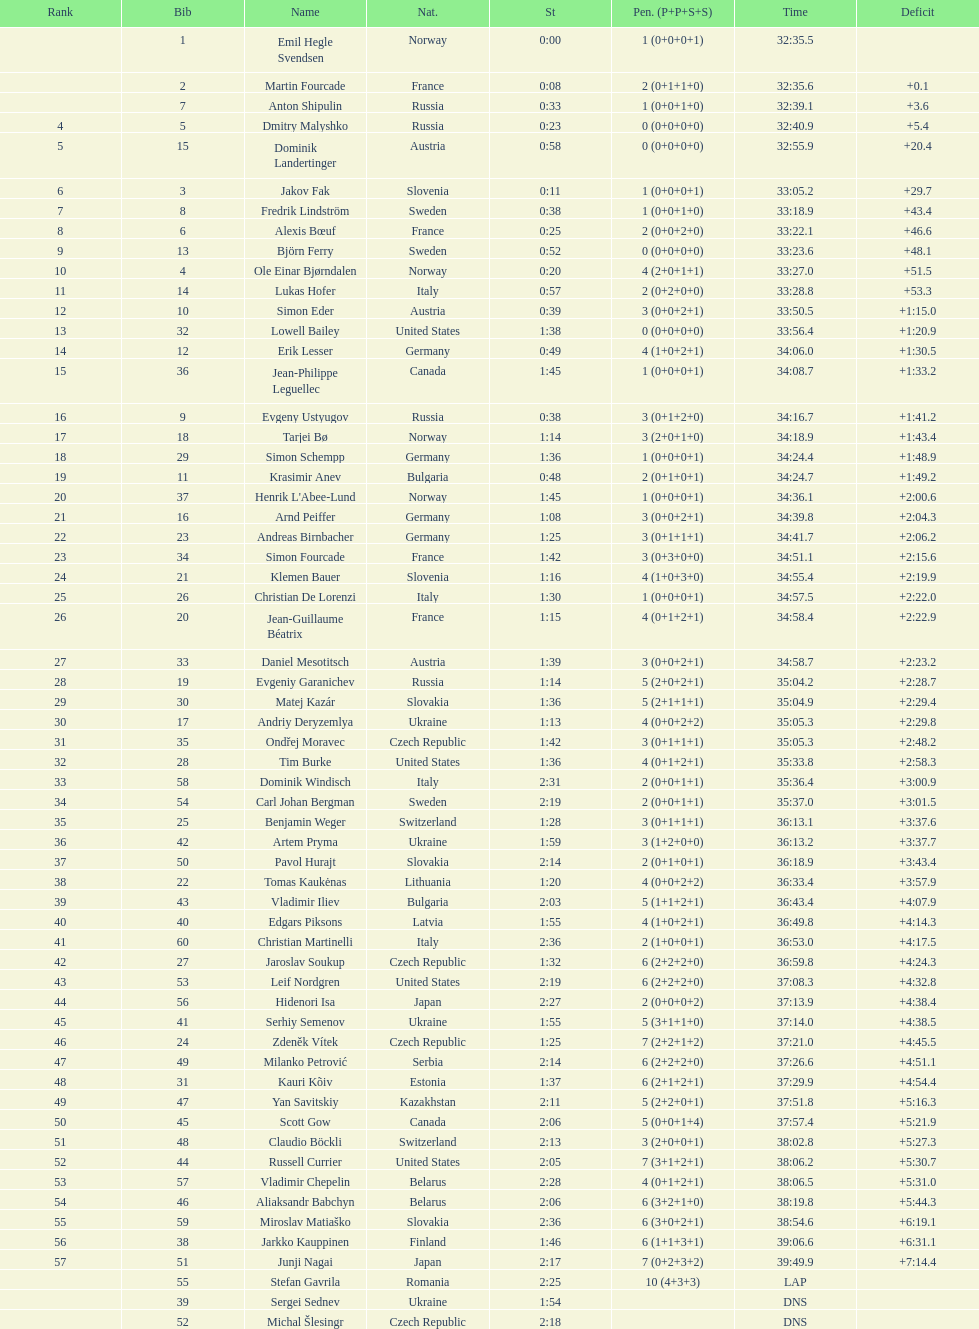How many united states competitors did not win medals? 4. 